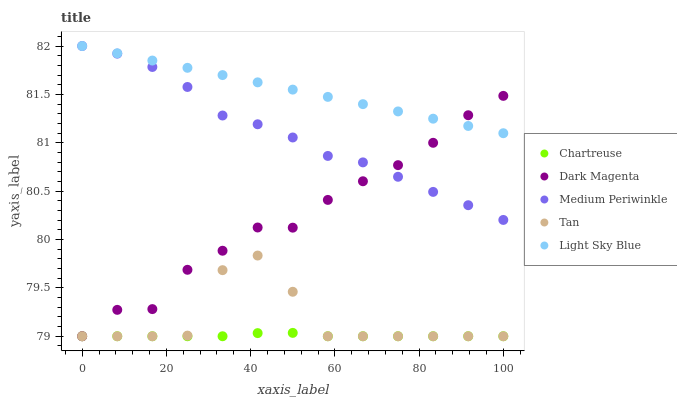Does Chartreuse have the minimum area under the curve?
Answer yes or no. Yes. Does Light Sky Blue have the maximum area under the curve?
Answer yes or no. Yes. Does Light Sky Blue have the minimum area under the curve?
Answer yes or no. No. Does Chartreuse have the maximum area under the curve?
Answer yes or no. No. Is Light Sky Blue the smoothest?
Answer yes or no. Yes. Is Tan the roughest?
Answer yes or no. Yes. Is Chartreuse the smoothest?
Answer yes or no. No. Is Chartreuse the roughest?
Answer yes or no. No. Does Tan have the lowest value?
Answer yes or no. Yes. Does Light Sky Blue have the lowest value?
Answer yes or no. No. Does Medium Periwinkle have the highest value?
Answer yes or no. Yes. Does Chartreuse have the highest value?
Answer yes or no. No. Is Tan less than Medium Periwinkle?
Answer yes or no. Yes. Is Light Sky Blue greater than Tan?
Answer yes or no. Yes. Does Light Sky Blue intersect Dark Magenta?
Answer yes or no. Yes. Is Light Sky Blue less than Dark Magenta?
Answer yes or no. No. Is Light Sky Blue greater than Dark Magenta?
Answer yes or no. No. Does Tan intersect Medium Periwinkle?
Answer yes or no. No. 